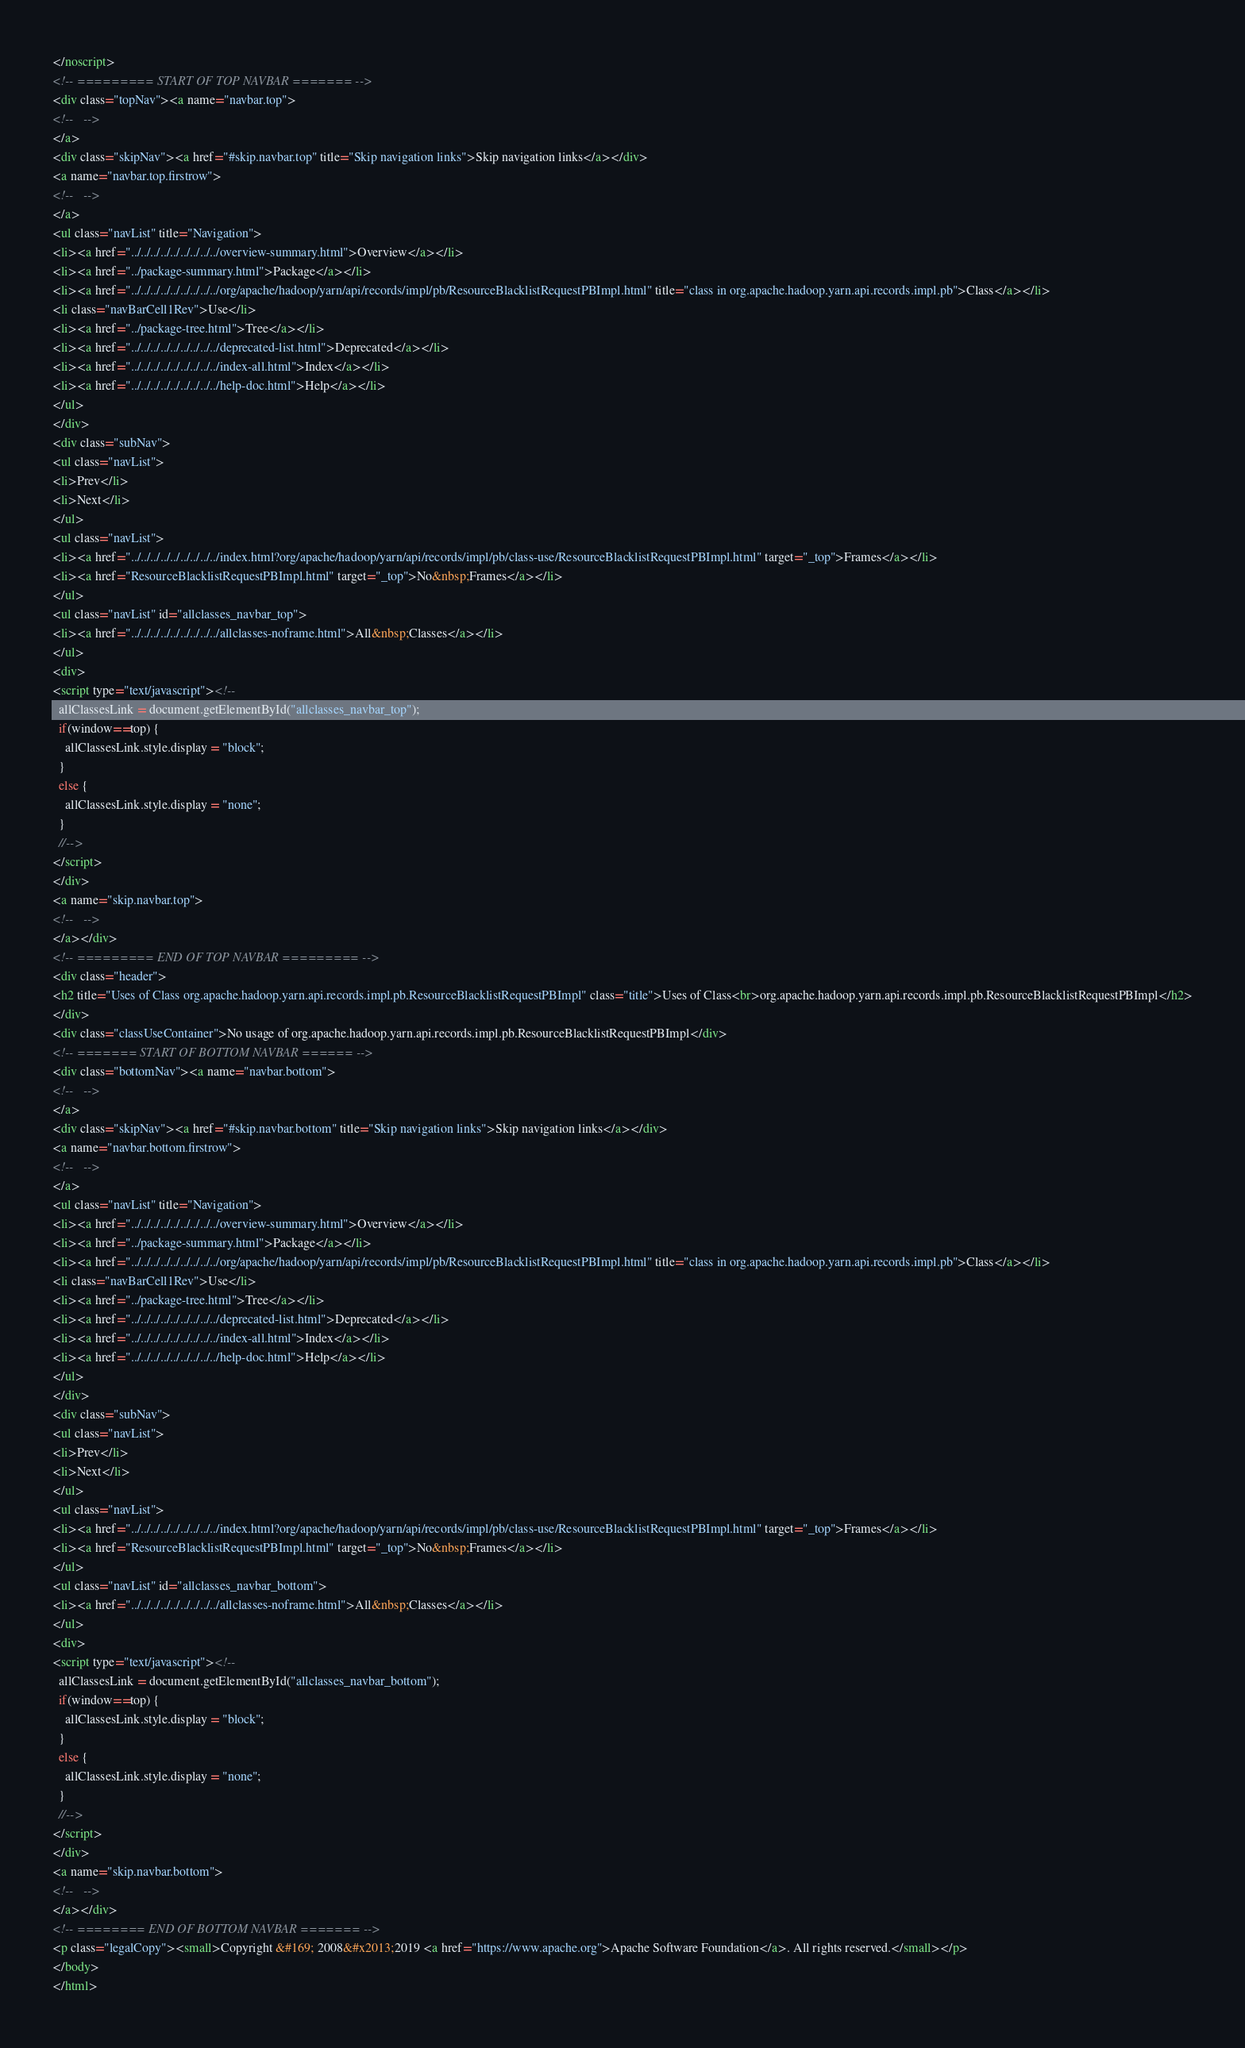<code> <loc_0><loc_0><loc_500><loc_500><_HTML_></noscript>
<!-- ========= START OF TOP NAVBAR ======= -->
<div class="topNav"><a name="navbar.top">
<!--   -->
</a>
<div class="skipNav"><a href="#skip.navbar.top" title="Skip navigation links">Skip navigation links</a></div>
<a name="navbar.top.firstrow">
<!--   -->
</a>
<ul class="navList" title="Navigation">
<li><a href="../../../../../../../../../overview-summary.html">Overview</a></li>
<li><a href="../package-summary.html">Package</a></li>
<li><a href="../../../../../../../../../org/apache/hadoop/yarn/api/records/impl/pb/ResourceBlacklistRequestPBImpl.html" title="class in org.apache.hadoop.yarn.api.records.impl.pb">Class</a></li>
<li class="navBarCell1Rev">Use</li>
<li><a href="../package-tree.html">Tree</a></li>
<li><a href="../../../../../../../../../deprecated-list.html">Deprecated</a></li>
<li><a href="../../../../../../../../../index-all.html">Index</a></li>
<li><a href="../../../../../../../../../help-doc.html">Help</a></li>
</ul>
</div>
<div class="subNav">
<ul class="navList">
<li>Prev</li>
<li>Next</li>
</ul>
<ul class="navList">
<li><a href="../../../../../../../../../index.html?org/apache/hadoop/yarn/api/records/impl/pb/class-use/ResourceBlacklistRequestPBImpl.html" target="_top">Frames</a></li>
<li><a href="ResourceBlacklistRequestPBImpl.html" target="_top">No&nbsp;Frames</a></li>
</ul>
<ul class="navList" id="allclasses_navbar_top">
<li><a href="../../../../../../../../../allclasses-noframe.html">All&nbsp;Classes</a></li>
</ul>
<div>
<script type="text/javascript"><!--
  allClassesLink = document.getElementById("allclasses_navbar_top");
  if(window==top) {
    allClassesLink.style.display = "block";
  }
  else {
    allClassesLink.style.display = "none";
  }
  //-->
</script>
</div>
<a name="skip.navbar.top">
<!--   -->
</a></div>
<!-- ========= END OF TOP NAVBAR ========= -->
<div class="header">
<h2 title="Uses of Class org.apache.hadoop.yarn.api.records.impl.pb.ResourceBlacklistRequestPBImpl" class="title">Uses of Class<br>org.apache.hadoop.yarn.api.records.impl.pb.ResourceBlacklistRequestPBImpl</h2>
</div>
<div class="classUseContainer">No usage of org.apache.hadoop.yarn.api.records.impl.pb.ResourceBlacklistRequestPBImpl</div>
<!-- ======= START OF BOTTOM NAVBAR ====== -->
<div class="bottomNav"><a name="navbar.bottom">
<!--   -->
</a>
<div class="skipNav"><a href="#skip.navbar.bottom" title="Skip navigation links">Skip navigation links</a></div>
<a name="navbar.bottom.firstrow">
<!--   -->
</a>
<ul class="navList" title="Navigation">
<li><a href="../../../../../../../../../overview-summary.html">Overview</a></li>
<li><a href="../package-summary.html">Package</a></li>
<li><a href="../../../../../../../../../org/apache/hadoop/yarn/api/records/impl/pb/ResourceBlacklistRequestPBImpl.html" title="class in org.apache.hadoop.yarn.api.records.impl.pb">Class</a></li>
<li class="navBarCell1Rev">Use</li>
<li><a href="../package-tree.html">Tree</a></li>
<li><a href="../../../../../../../../../deprecated-list.html">Deprecated</a></li>
<li><a href="../../../../../../../../../index-all.html">Index</a></li>
<li><a href="../../../../../../../../../help-doc.html">Help</a></li>
</ul>
</div>
<div class="subNav">
<ul class="navList">
<li>Prev</li>
<li>Next</li>
</ul>
<ul class="navList">
<li><a href="../../../../../../../../../index.html?org/apache/hadoop/yarn/api/records/impl/pb/class-use/ResourceBlacklistRequestPBImpl.html" target="_top">Frames</a></li>
<li><a href="ResourceBlacklistRequestPBImpl.html" target="_top">No&nbsp;Frames</a></li>
</ul>
<ul class="navList" id="allclasses_navbar_bottom">
<li><a href="../../../../../../../../../allclasses-noframe.html">All&nbsp;Classes</a></li>
</ul>
<div>
<script type="text/javascript"><!--
  allClassesLink = document.getElementById("allclasses_navbar_bottom");
  if(window==top) {
    allClassesLink.style.display = "block";
  }
  else {
    allClassesLink.style.display = "none";
  }
  //-->
</script>
</div>
<a name="skip.navbar.bottom">
<!--   -->
</a></div>
<!-- ======== END OF BOTTOM NAVBAR ======= -->
<p class="legalCopy"><small>Copyright &#169; 2008&#x2013;2019 <a href="https://www.apache.org">Apache Software Foundation</a>. All rights reserved.</small></p>
</body>
</html>
</code> 